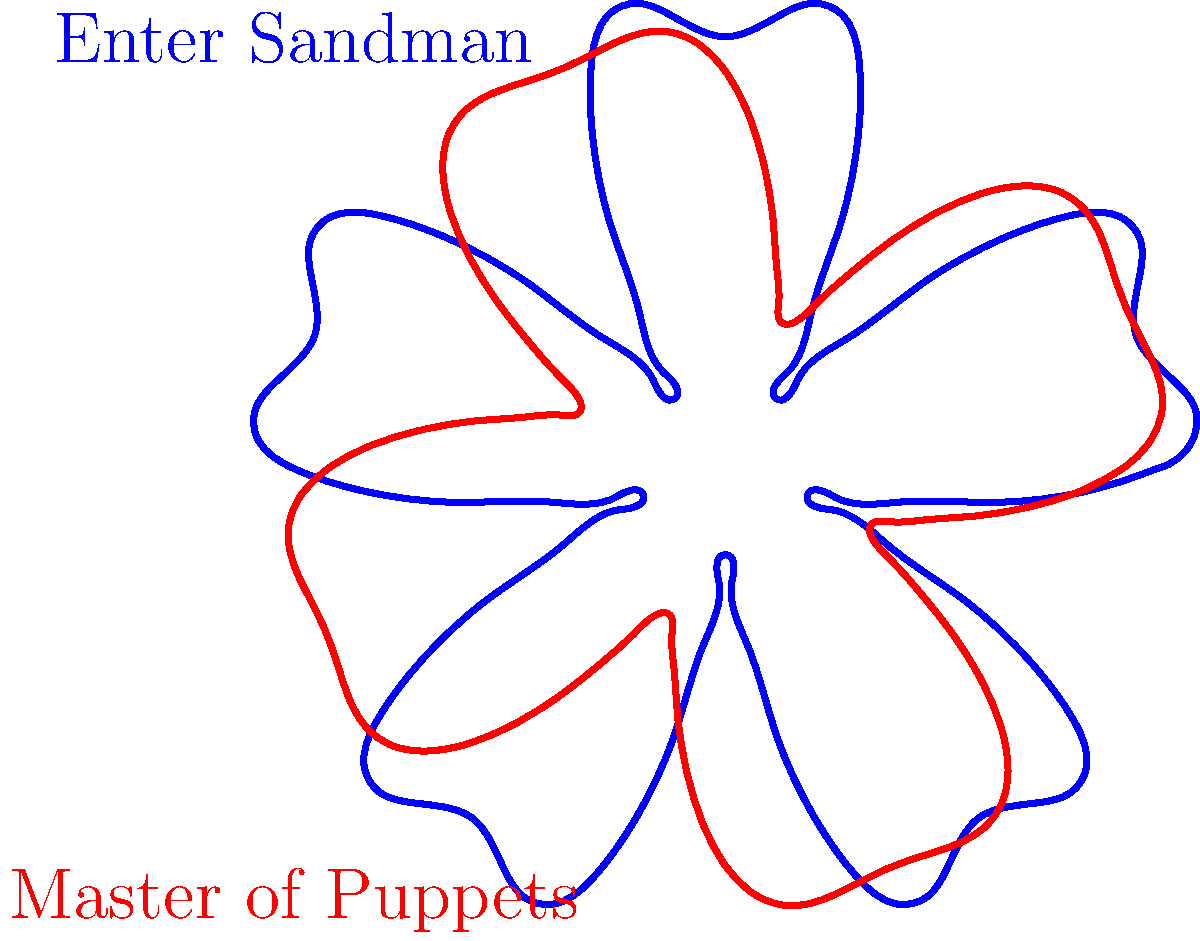The polar graphs shown represent the sound wave patterns of two iconic Metallica guitar riffs. The blue graph corresponds to "Enter Sandman," while the red graph represents "Master of Puppets." Based on these visualizations, which riff appears to have a more complex wave pattern with higher frequency components? To determine which riff has a more complex wave pattern with higher frequency components, we need to analyze the characteristics of both polar graphs:

1. "Enter Sandman" (blue graph):
   - The graph shows a pattern with five main lobes.
   - There are smaller, secondary oscillations visible within each lobe.
   - The overall shape is relatively symmetrical.

2. "Master of Puppets" (red graph):
   - The graph displays four main lobes.
   - The lobes appear smoother and more uniform compared to "Enter Sandman."
   - There are fewer visible secondary oscillations within the lobes.

3. Comparing the graphs:
   - The blue graph ("Enter Sandman") has more intricate details and variations in its pattern.
   - The presence of more visible secondary oscillations in the blue graph suggests higher frequency components.
   - The red graph ("Master of Puppets") appears simpler and smoother in comparison.

4. Interpreting the results:
   - More complex wave patterns typically indicate the presence of higher frequency components and harmonics.
   - The increased complexity and detail in the "Enter Sandman" graph suggest that it contains more high-frequency elements in its sound.

Therefore, based on these polar graph representations, "Enter Sandman" appears to have a more complex wave pattern with higher frequency components compared to "Master of Puppets."
Answer: Enter Sandman 